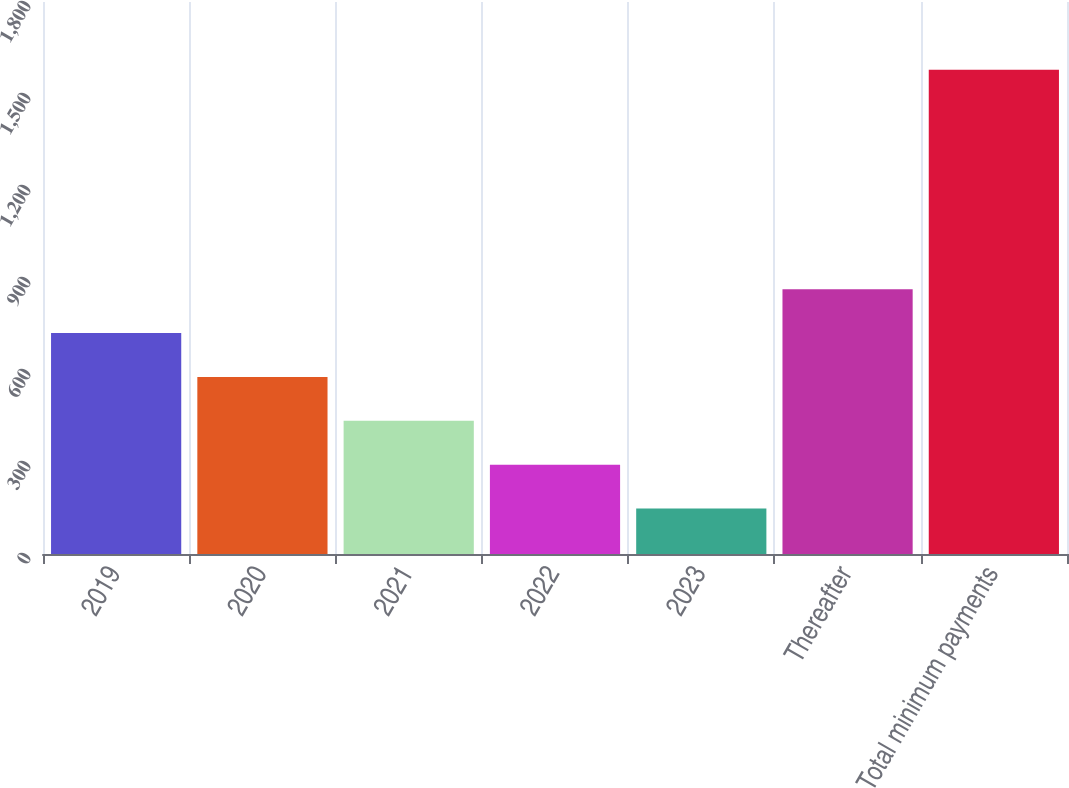Convert chart to OTSL. <chart><loc_0><loc_0><loc_500><loc_500><bar_chart><fcel>2019<fcel>2020<fcel>2021<fcel>2022<fcel>2023<fcel>Thereafter<fcel>Total minimum payments<nl><fcel>720.4<fcel>577.3<fcel>434.2<fcel>291.1<fcel>148<fcel>863.5<fcel>1579<nl></chart> 